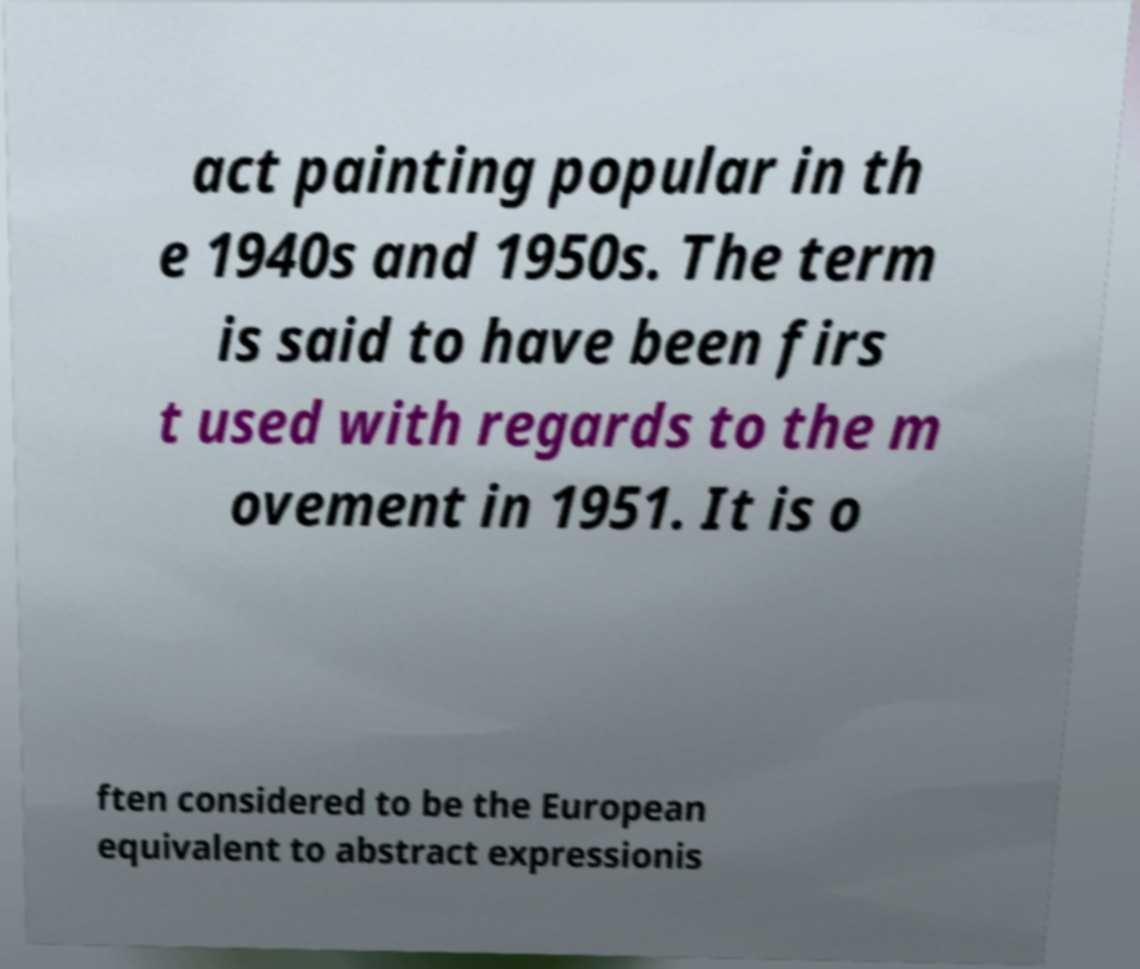Can you read and provide the text displayed in the image?This photo seems to have some interesting text. Can you extract and type it out for me? act painting popular in th e 1940s and 1950s. The term is said to have been firs t used with regards to the m ovement in 1951. It is o ften considered to be the European equivalent to abstract expressionis 